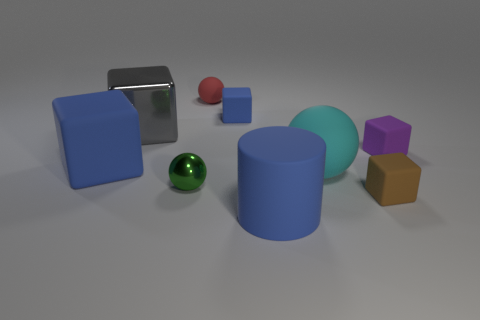What number of cyan rubber things are the same shape as the small blue rubber object?
Make the answer very short. 0. There is a large blue thing that is behind the big blue thing in front of the brown rubber block; what is it made of?
Your answer should be very brief. Rubber. What size is the blue rubber thing behind the large metallic block?
Give a very brief answer. Small. What number of cyan things are either big metal cubes or matte things?
Keep it short and to the point. 1. There is a large cyan object that is the same shape as the tiny metal thing; what is it made of?
Keep it short and to the point. Rubber. Are there an equal number of big cyan spheres that are behind the gray metal object and tiny purple rubber things?
Offer a terse response. No. What is the size of the object that is both left of the brown rubber block and on the right side of the blue matte cylinder?
Provide a short and direct response. Large. Are there any other things that have the same color as the tiny rubber sphere?
Your answer should be very brief. No. There is a shiny thing behind the tiny sphere that is in front of the purple matte cube; what is its size?
Provide a succinct answer. Large. The small object that is both left of the cyan sphere and right of the small red thing is what color?
Give a very brief answer. Blue. 